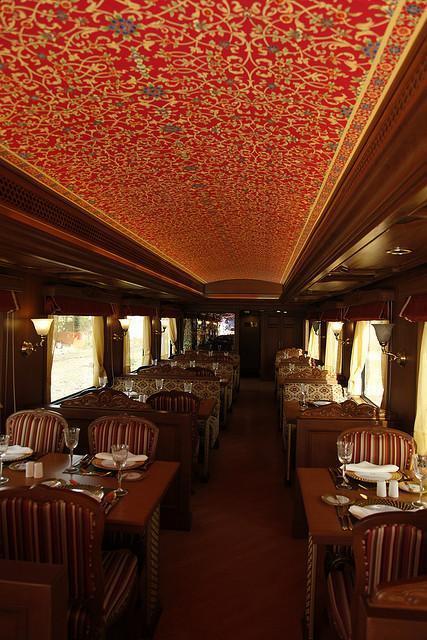How many chairs are in the picture?
Give a very brief answer. 5. How many dining tables are there?
Give a very brief answer. 2. 